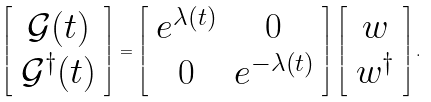<formula> <loc_0><loc_0><loc_500><loc_500>\left [ \begin{array} { c } \mathcal { G } ( t ) \\ \mathcal { G } ^ { \dagger } ( t ) \end{array} \right ] = \left [ \begin{array} { c c } e ^ { \lambda ( t ) } & 0 \\ 0 & e ^ { - \lambda ( t ) } \end{array} \right ] \left [ \begin{array} { c c } w \\ w ^ { \dagger } \end{array} \right ] .</formula> 